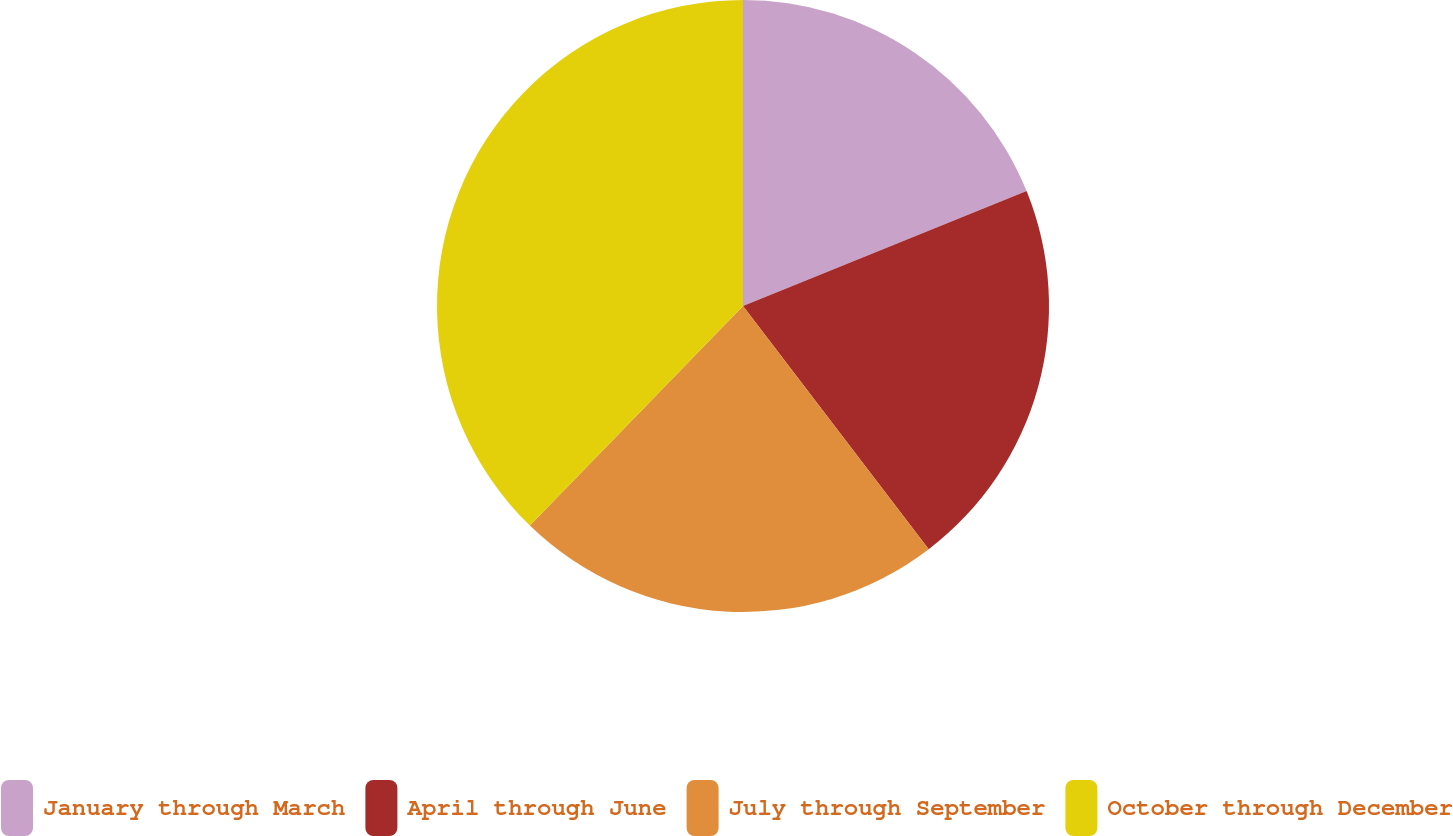Convert chart to OTSL. <chart><loc_0><loc_0><loc_500><loc_500><pie_chart><fcel>January through March<fcel>April through June<fcel>July through September<fcel>October through December<nl><fcel>18.87%<fcel>20.75%<fcel>22.64%<fcel>37.74%<nl></chart> 